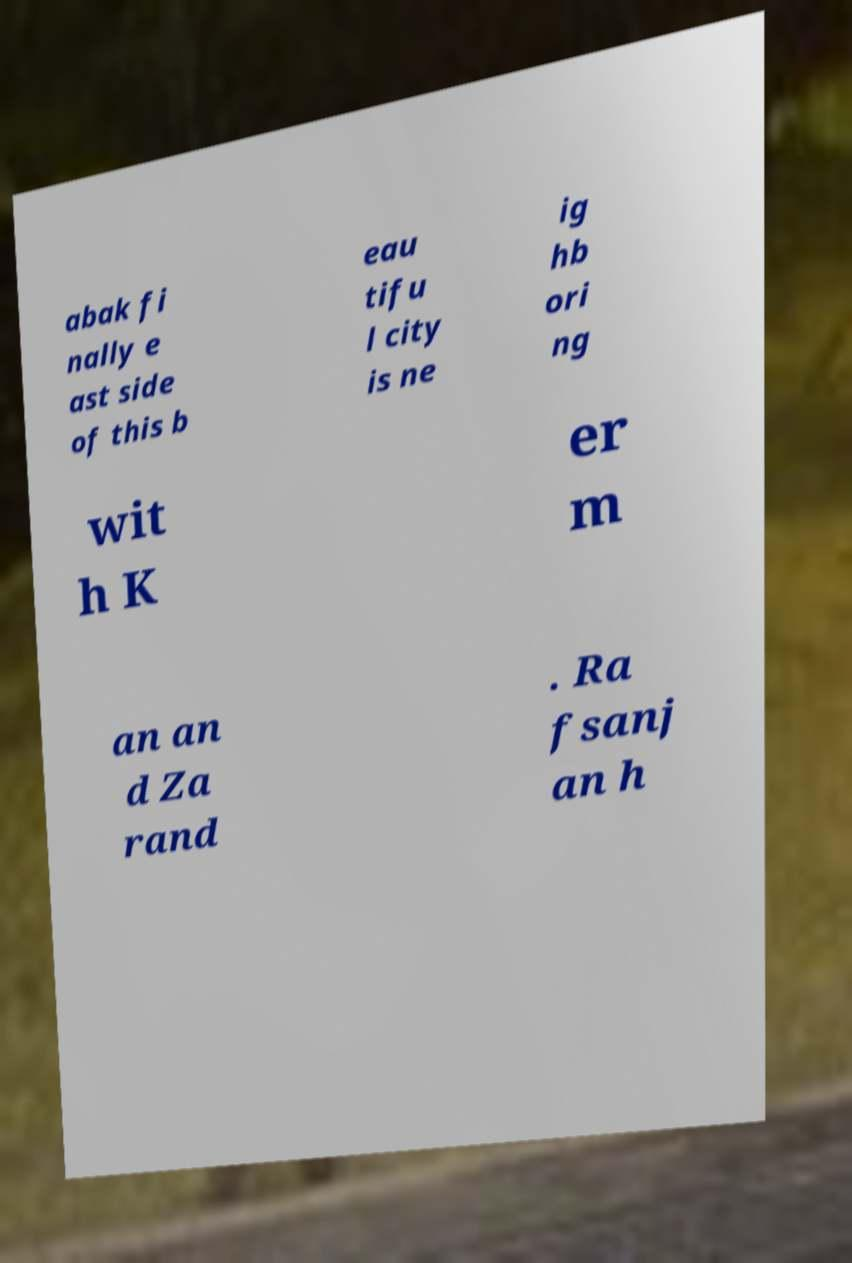Can you read and provide the text displayed in the image?This photo seems to have some interesting text. Can you extract and type it out for me? abak fi nally e ast side of this b eau tifu l city is ne ig hb ori ng wit h K er m an an d Za rand . Ra fsanj an h 